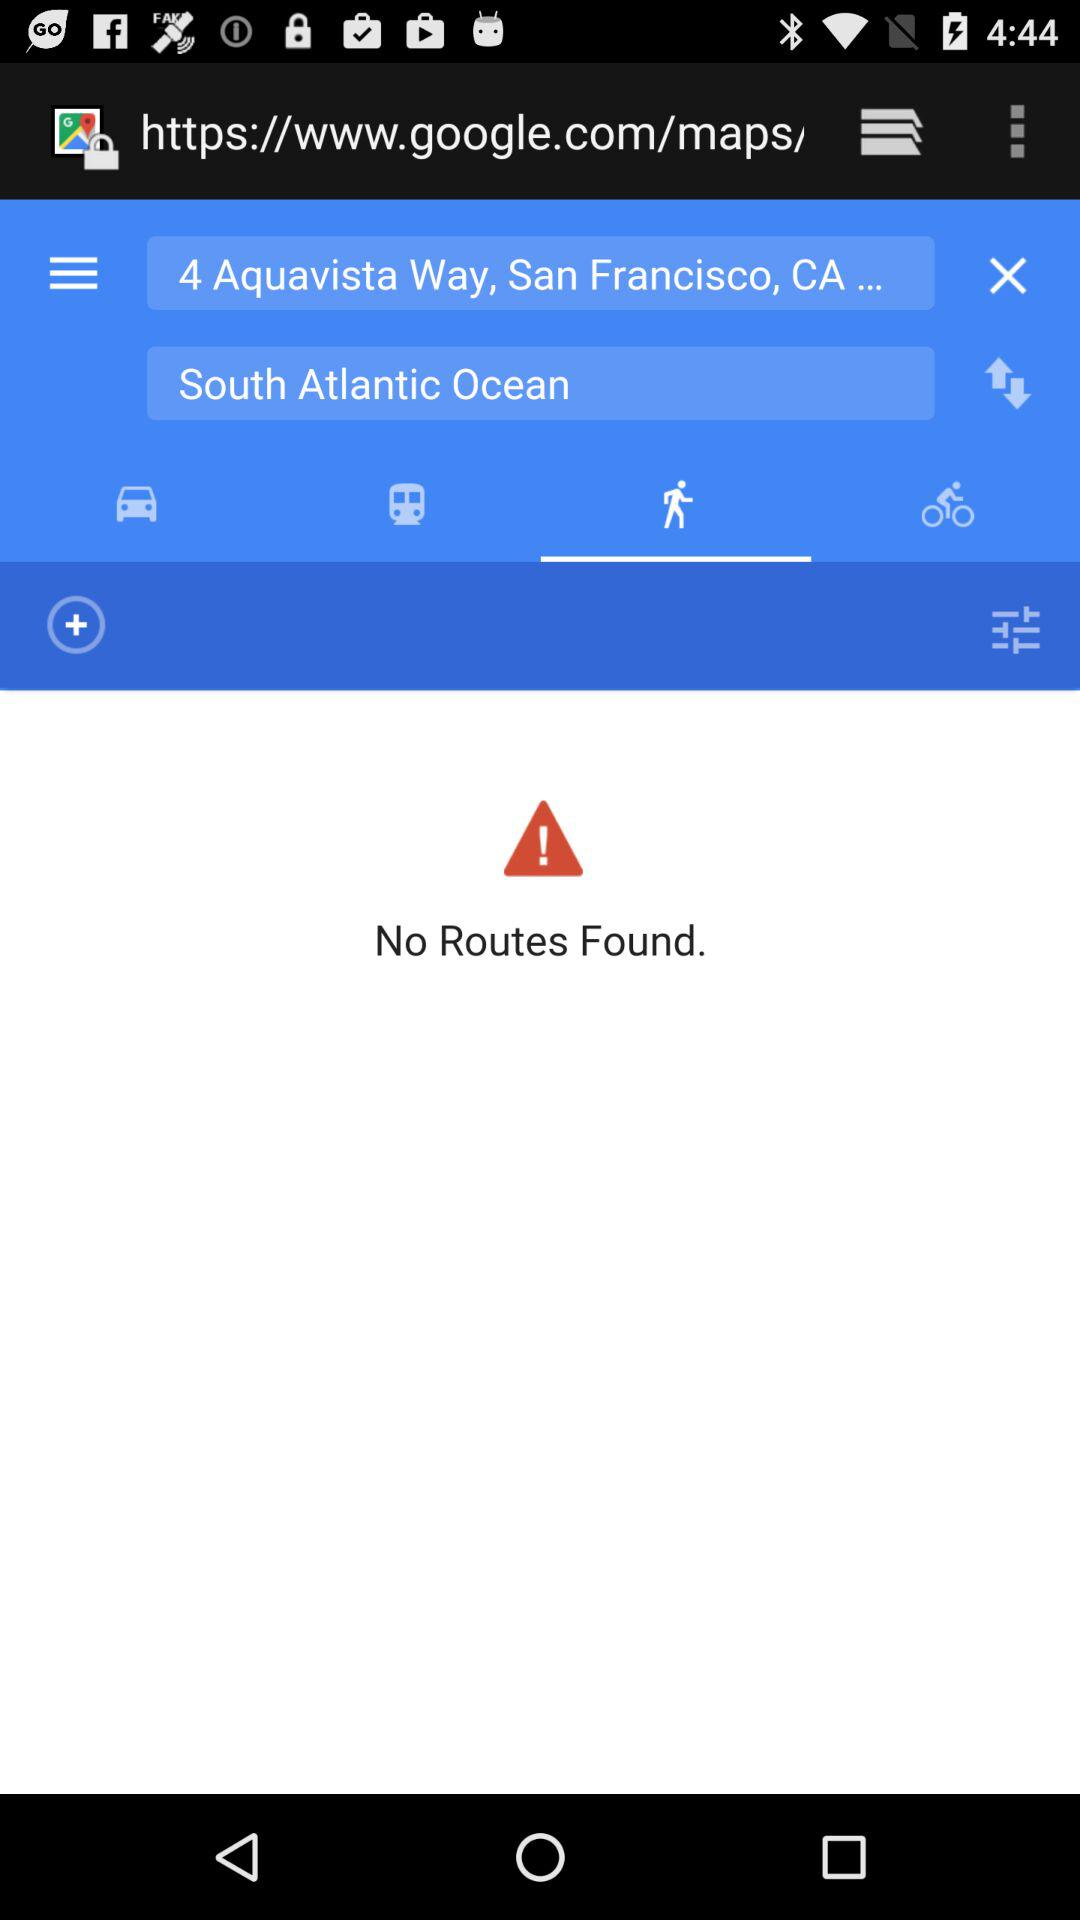Is there any route found? There is no route found. 